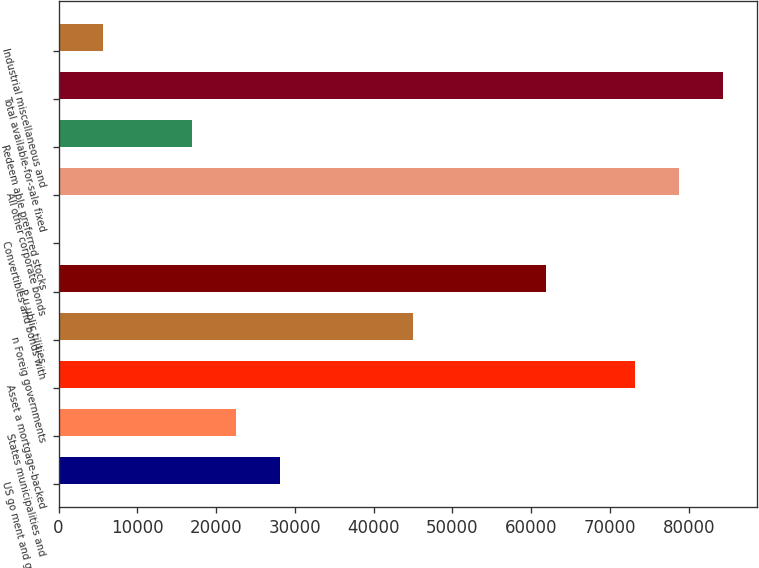Convert chart to OTSL. <chart><loc_0><loc_0><loc_500><loc_500><bar_chart><fcel>US go ment and government<fcel>States municipalities and<fcel>Asset a mortgage-backed<fcel>n Foreig governments<fcel>P u ublic tilities<fcel>Convertibles and bonds with<fcel>All other corporate bonds<fcel>Redeem able preferred stocks<fcel>Total available-for-sale fixed<fcel>Industrial miscellaneous and<nl><fcel>28142.5<fcel>22515.8<fcel>73156.1<fcel>45022.6<fcel>61902.7<fcel>9<fcel>78782.8<fcel>16889.1<fcel>84409.5<fcel>5635.7<nl></chart> 